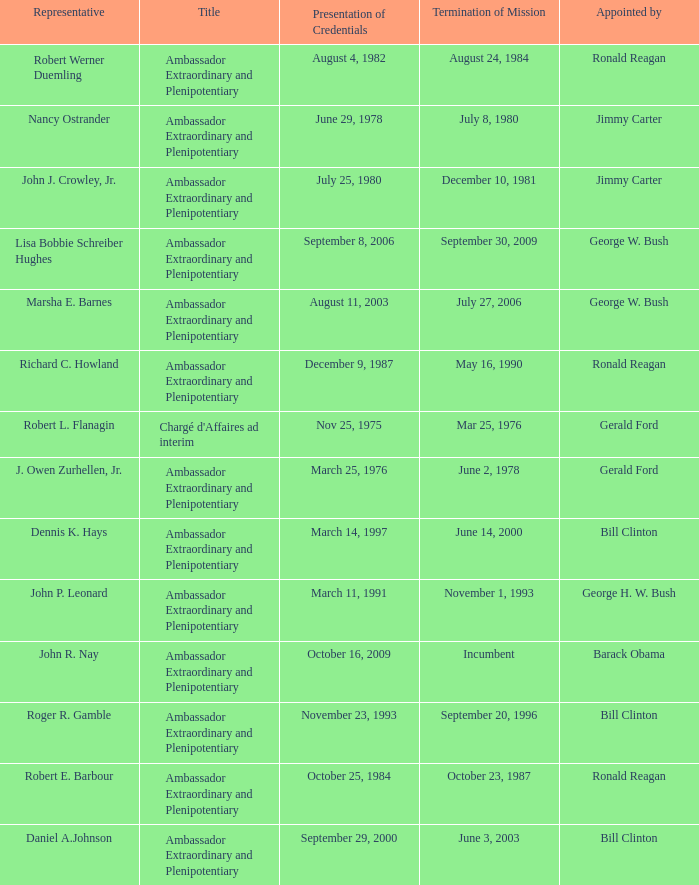Which representative was the Ambassador Extraordinary and Plenipotentiary and had a Termination of Mission date September 20, 1996? Roger R. Gamble. 